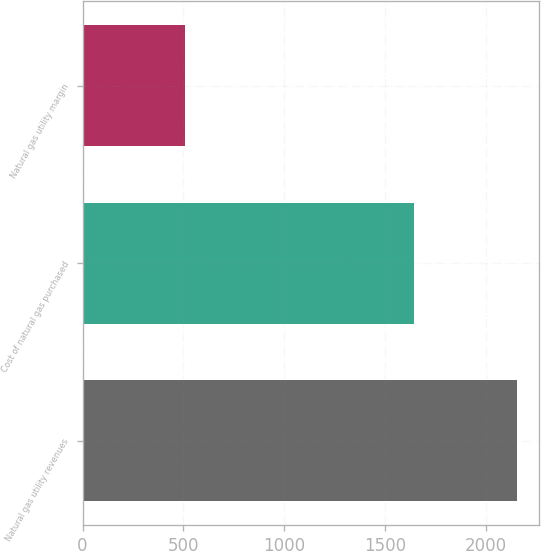Convert chart. <chart><loc_0><loc_0><loc_500><loc_500><bar_chart><fcel>Natural gas utility revenues<fcel>Cost of natural gas purchased<fcel>Natural gas utility margin<nl><fcel>2156<fcel>1645<fcel>511<nl></chart> 